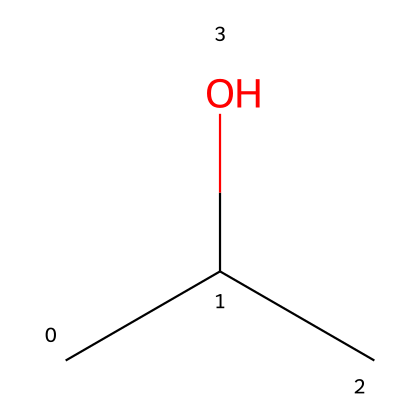What is the common name of the chemical represented by this structure? The chemical structure with the SMILES CC(C)O corresponds to isopropyl alcohol, which is a common name for 2-propanol.
Answer: isopropyl alcohol How many carbon atoms are in the structure? By analyzing the SMILES representation, CC(C)O shows three carbon (C) atoms connected in a central manner, indicating there are a total of three carbon atoms.
Answer: three What type of functional group is present in isopropyl alcohol? The alcohol group in the structure is indicated by the presence of the hydroxyl (-OH) functional group, which is characteristic of alcohols.
Answer: alcohol Is isopropyl alcohol considered a flammable liquid? Based on its chemical properties, isopropyl alcohol is known to be flammable, typically igniting at room temperature, confirming its classification as a flammable liquid.
Answer: yes How many hydrogen atoms are attached to this molecule? The structural interpretation of CC(C)O results in seven hydrogen (H) atoms surrounding the three carbon atoms and the -OH group, leading to the conclusion that there are seven total hydrogen atoms.
Answer: seven What is the boiling point range of isopropyl alcohol? Isopropyl alcohol has a boiling point of approximately 82-83 degrees Celsius; this information is based on its chemical properties and classification.
Answer: 82-83 degrees Celsius 